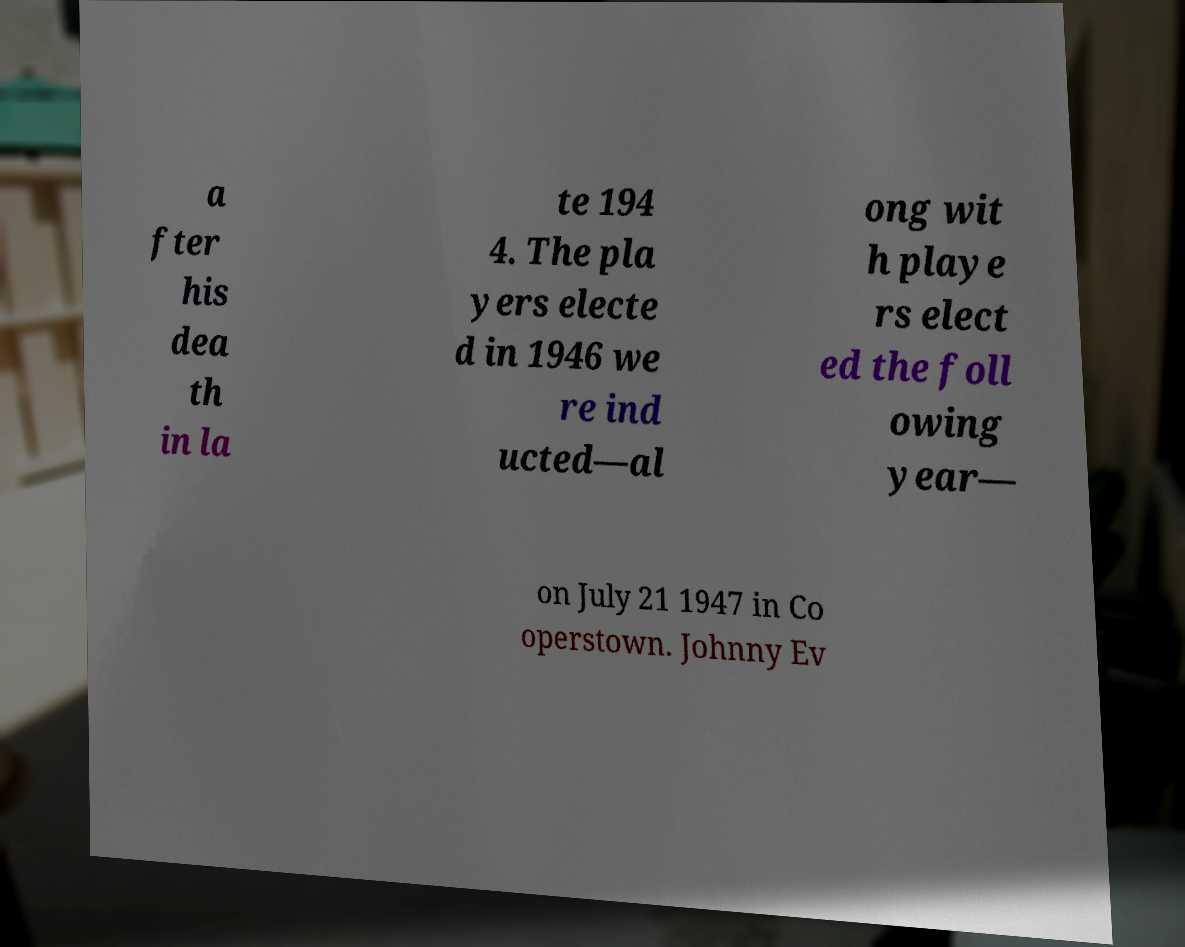Can you accurately transcribe the text from the provided image for me? a fter his dea th in la te 194 4. The pla yers electe d in 1946 we re ind ucted—al ong wit h playe rs elect ed the foll owing year— on July 21 1947 in Co operstown. Johnny Ev 